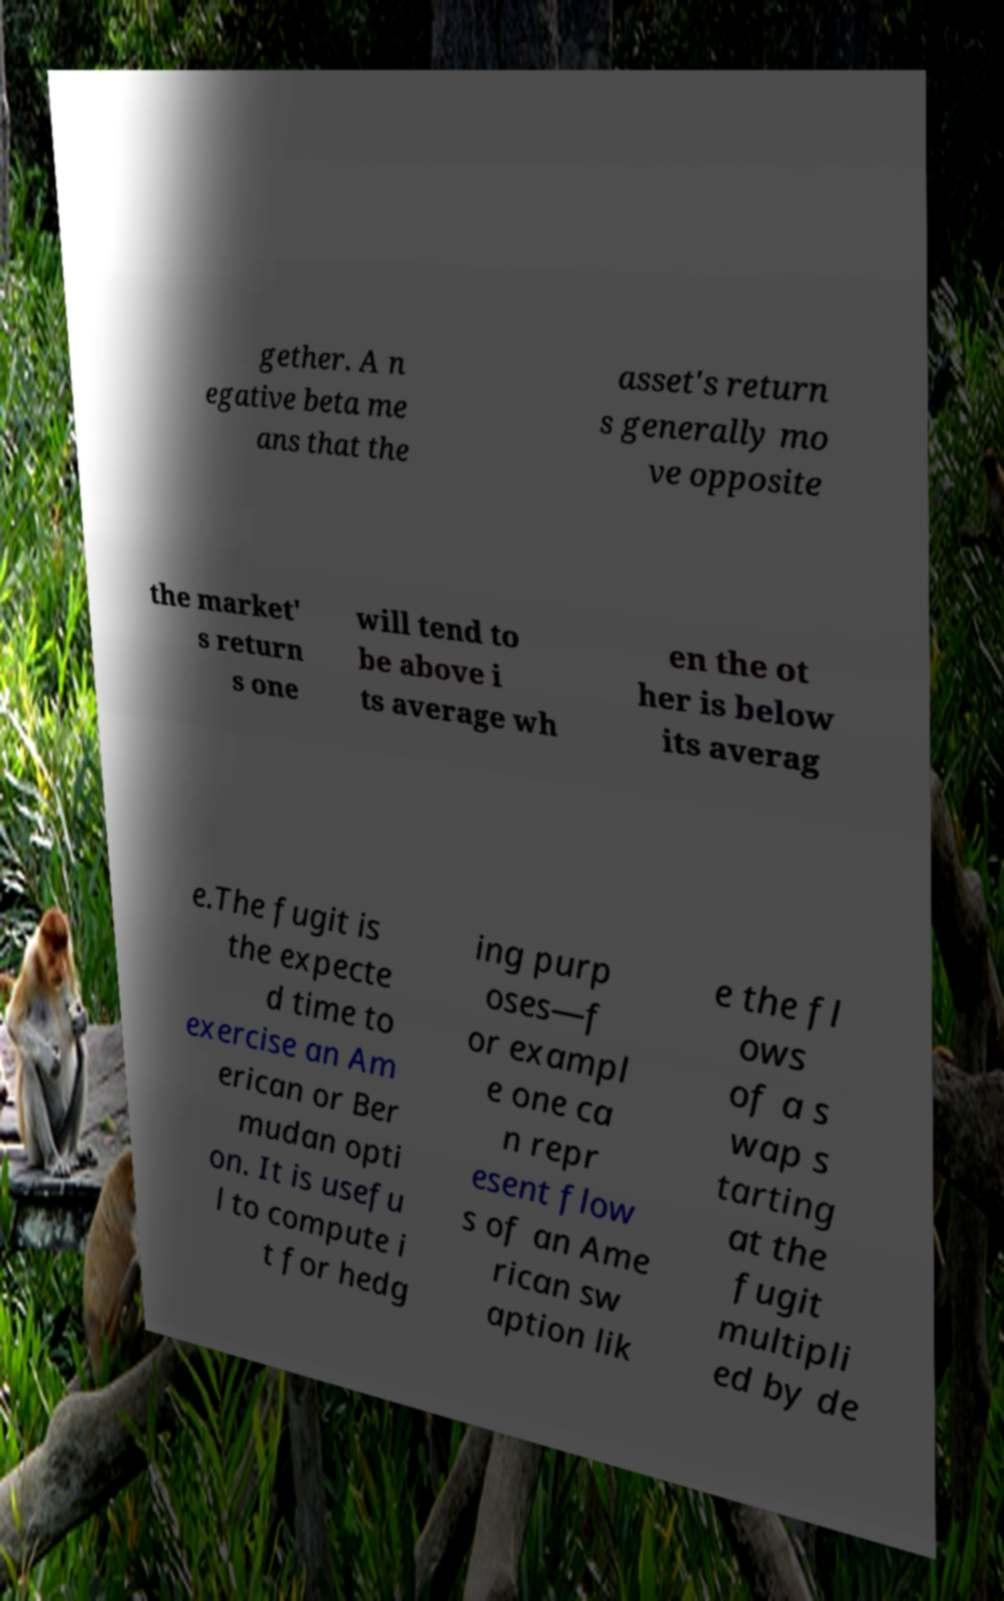I need the written content from this picture converted into text. Can you do that? gether. A n egative beta me ans that the asset's return s generally mo ve opposite the market' s return s one will tend to be above i ts average wh en the ot her is below its averag e.The fugit is the expecte d time to exercise an Am erican or Ber mudan opti on. It is usefu l to compute i t for hedg ing purp oses—f or exampl e one ca n repr esent flow s of an Ame rican sw aption lik e the fl ows of a s wap s tarting at the fugit multipli ed by de 